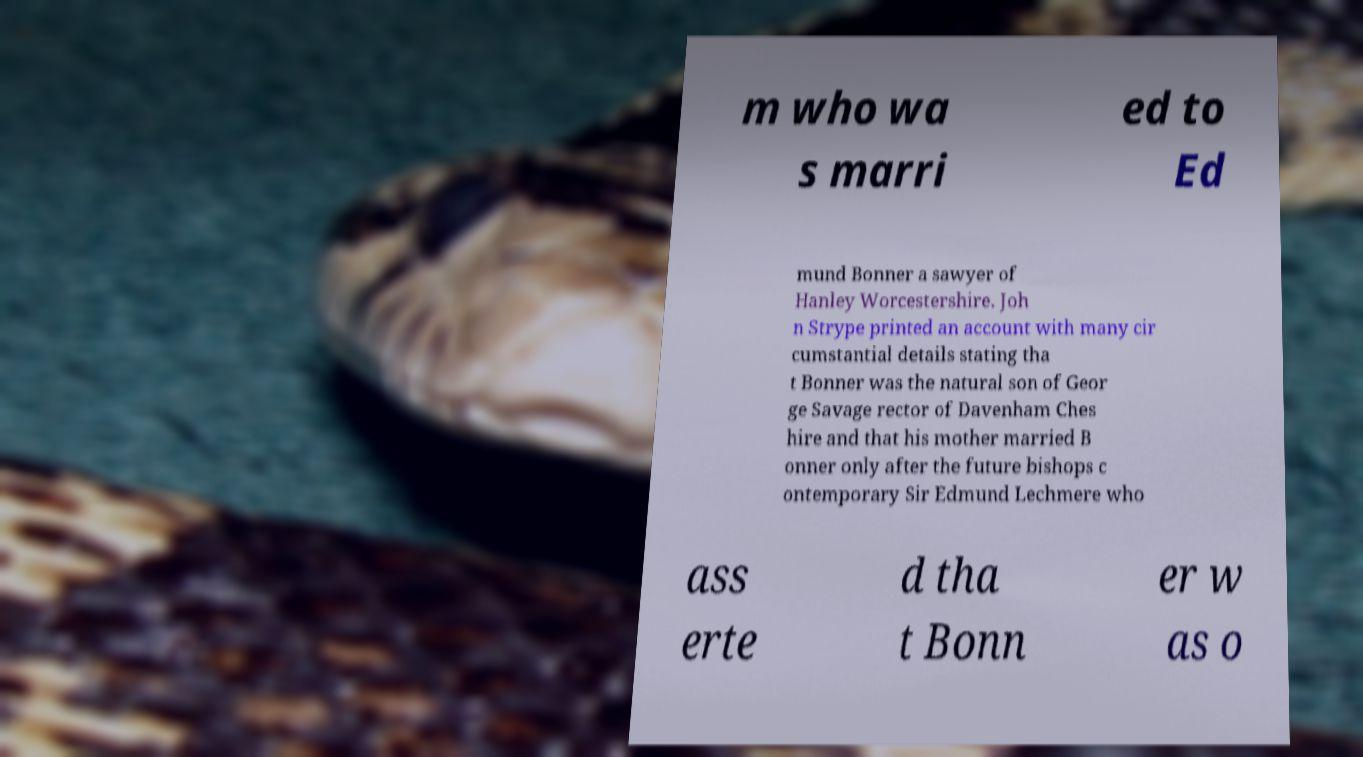Please identify and transcribe the text found in this image. m who wa s marri ed to Ed mund Bonner a sawyer of Hanley Worcestershire. Joh n Strype printed an account with many cir cumstantial details stating tha t Bonner was the natural son of Geor ge Savage rector of Davenham Ches hire and that his mother married B onner only after the future bishops c ontemporary Sir Edmund Lechmere who ass erte d tha t Bonn er w as o 